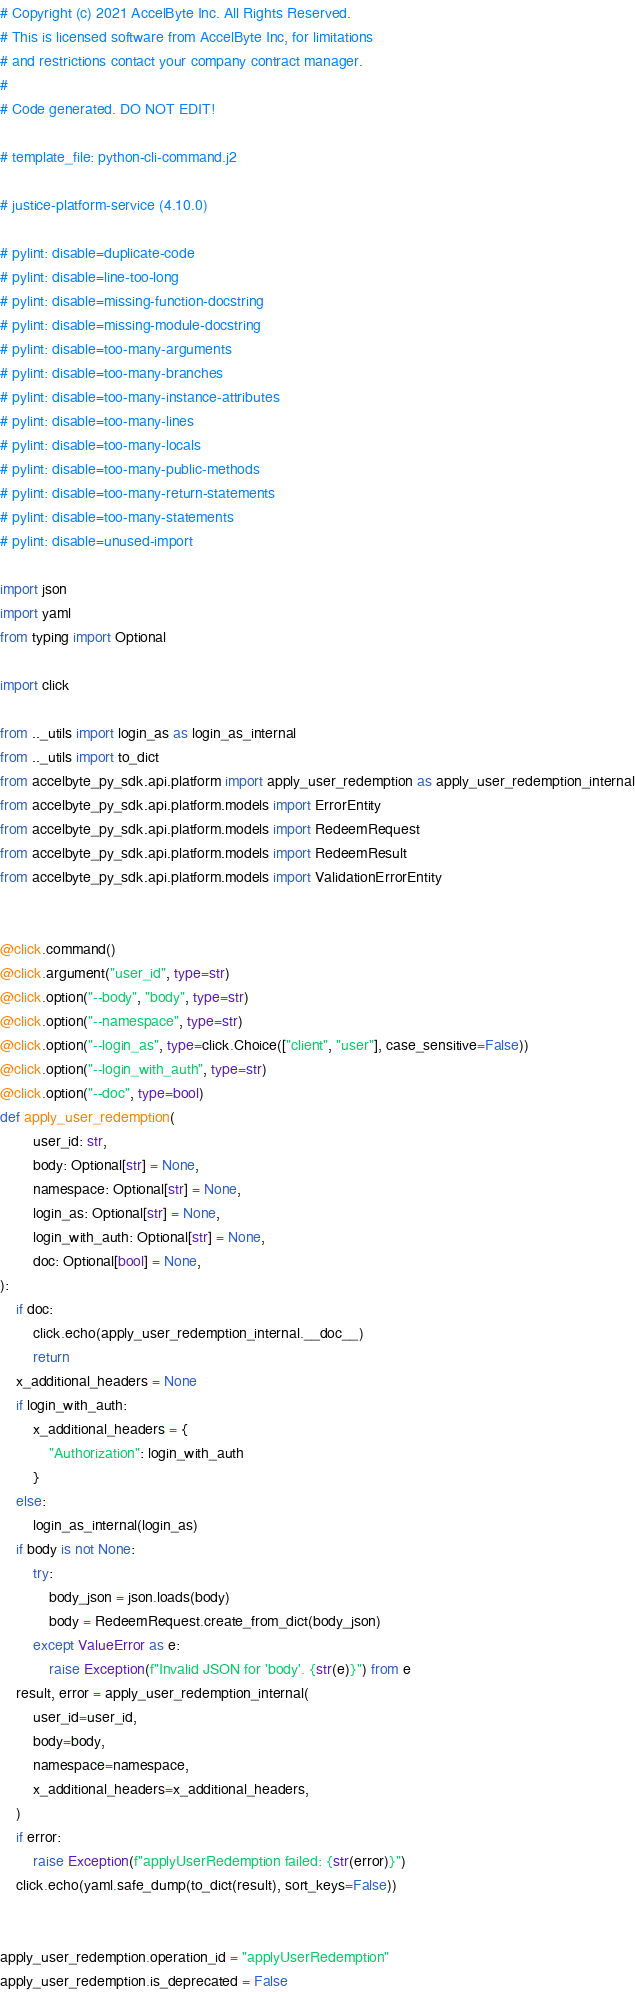<code> <loc_0><loc_0><loc_500><loc_500><_Python_># Copyright (c) 2021 AccelByte Inc. All Rights Reserved.
# This is licensed software from AccelByte Inc, for limitations
# and restrictions contact your company contract manager.
#
# Code generated. DO NOT EDIT!

# template_file: python-cli-command.j2

# justice-platform-service (4.10.0)

# pylint: disable=duplicate-code
# pylint: disable=line-too-long
# pylint: disable=missing-function-docstring
# pylint: disable=missing-module-docstring
# pylint: disable=too-many-arguments
# pylint: disable=too-many-branches
# pylint: disable=too-many-instance-attributes
# pylint: disable=too-many-lines
# pylint: disable=too-many-locals
# pylint: disable=too-many-public-methods
# pylint: disable=too-many-return-statements
# pylint: disable=too-many-statements
# pylint: disable=unused-import

import json
import yaml
from typing import Optional

import click

from .._utils import login_as as login_as_internal
from .._utils import to_dict
from accelbyte_py_sdk.api.platform import apply_user_redemption as apply_user_redemption_internal
from accelbyte_py_sdk.api.platform.models import ErrorEntity
from accelbyte_py_sdk.api.platform.models import RedeemRequest
from accelbyte_py_sdk.api.platform.models import RedeemResult
from accelbyte_py_sdk.api.platform.models import ValidationErrorEntity


@click.command()
@click.argument("user_id", type=str)
@click.option("--body", "body", type=str)
@click.option("--namespace", type=str)
@click.option("--login_as", type=click.Choice(["client", "user"], case_sensitive=False))
@click.option("--login_with_auth", type=str)
@click.option("--doc", type=bool)
def apply_user_redemption(
        user_id: str,
        body: Optional[str] = None,
        namespace: Optional[str] = None,
        login_as: Optional[str] = None,
        login_with_auth: Optional[str] = None,
        doc: Optional[bool] = None,
):
    if doc:
        click.echo(apply_user_redemption_internal.__doc__)
        return
    x_additional_headers = None
    if login_with_auth:
        x_additional_headers = {
            "Authorization": login_with_auth
        }
    else:
        login_as_internal(login_as)
    if body is not None:
        try:
            body_json = json.loads(body)
            body = RedeemRequest.create_from_dict(body_json)
        except ValueError as e:
            raise Exception(f"Invalid JSON for 'body'. {str(e)}") from e
    result, error = apply_user_redemption_internal(
        user_id=user_id,
        body=body,
        namespace=namespace,
        x_additional_headers=x_additional_headers,
    )
    if error:
        raise Exception(f"applyUserRedemption failed: {str(error)}")
    click.echo(yaml.safe_dump(to_dict(result), sort_keys=False))


apply_user_redemption.operation_id = "applyUserRedemption"
apply_user_redemption.is_deprecated = False
</code> 